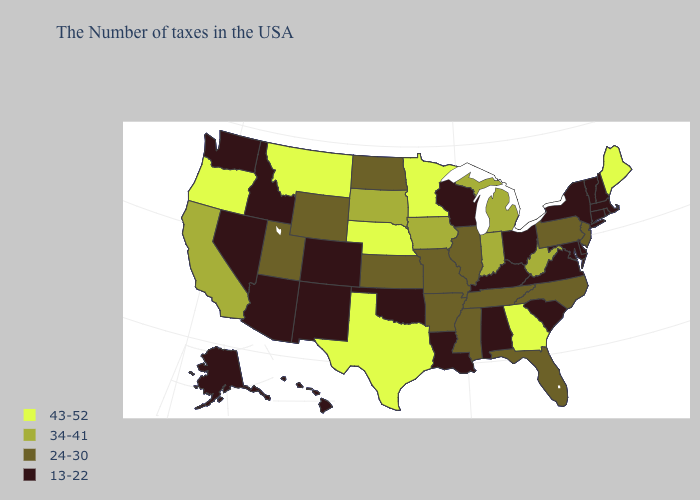What is the value of Mississippi?
Concise answer only. 24-30. Does the map have missing data?
Answer briefly. No. Which states have the lowest value in the Northeast?
Keep it brief. Massachusetts, Rhode Island, New Hampshire, Vermont, Connecticut, New York. Which states have the lowest value in the MidWest?
Concise answer only. Ohio, Wisconsin. Name the states that have a value in the range 34-41?
Be succinct. West Virginia, Michigan, Indiana, Iowa, South Dakota, California. What is the value of Pennsylvania?
Quick response, please. 24-30. What is the value of Louisiana?
Answer briefly. 13-22. Name the states that have a value in the range 13-22?
Quick response, please. Massachusetts, Rhode Island, New Hampshire, Vermont, Connecticut, New York, Delaware, Maryland, Virginia, South Carolina, Ohio, Kentucky, Alabama, Wisconsin, Louisiana, Oklahoma, Colorado, New Mexico, Arizona, Idaho, Nevada, Washington, Alaska, Hawaii. What is the value of Tennessee?
Short answer required. 24-30. What is the lowest value in the West?
Quick response, please. 13-22. Does New Jersey have the lowest value in the Northeast?
Keep it brief. No. Among the states that border North Dakota , which have the lowest value?
Write a very short answer. South Dakota. Name the states that have a value in the range 24-30?
Quick response, please. New Jersey, Pennsylvania, North Carolina, Florida, Tennessee, Illinois, Mississippi, Missouri, Arkansas, Kansas, North Dakota, Wyoming, Utah. How many symbols are there in the legend?
Short answer required. 4. What is the value of Illinois?
Be succinct. 24-30. 